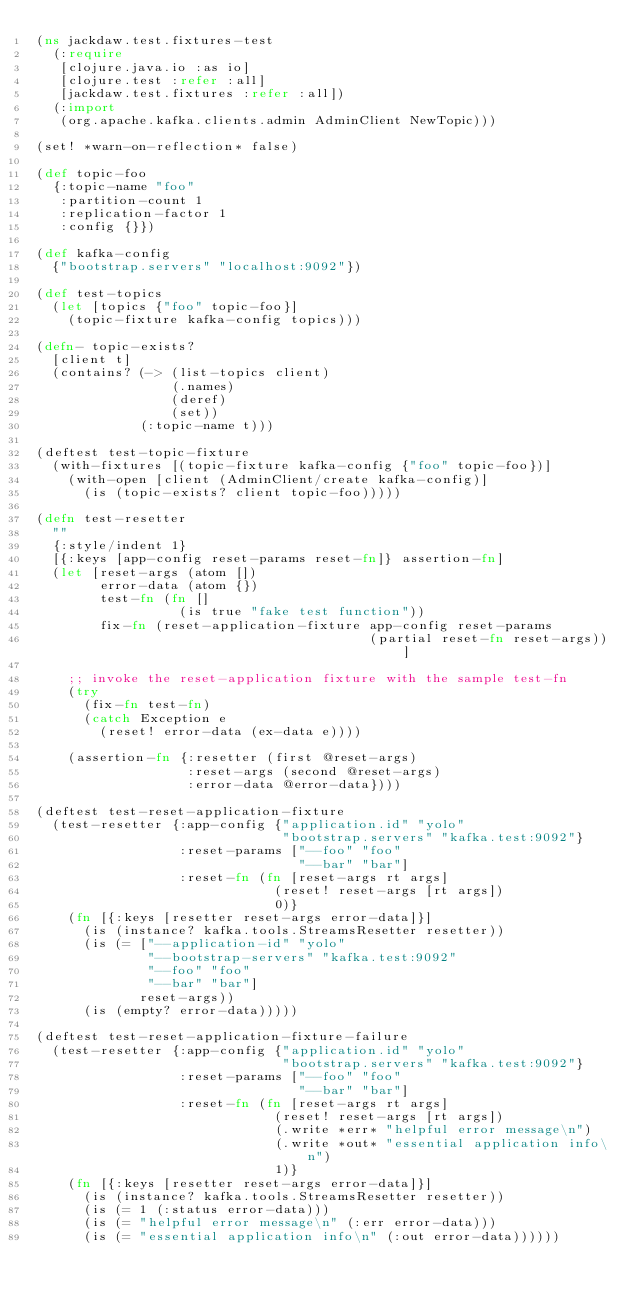Convert code to text. <code><loc_0><loc_0><loc_500><loc_500><_Clojure_>(ns jackdaw.test.fixtures-test
  (:require
   [clojure.java.io :as io]
   [clojure.test :refer :all]
   [jackdaw.test.fixtures :refer :all])
  (:import
   (org.apache.kafka.clients.admin AdminClient NewTopic)))

(set! *warn-on-reflection* false)

(def topic-foo
  {:topic-name "foo"
   :partition-count 1
   :replication-factor 1
   :config {}})

(def kafka-config
  {"bootstrap.servers" "localhost:9092"})

(def test-topics
  (let [topics {"foo" topic-foo}]
    (topic-fixture kafka-config topics)))

(defn- topic-exists?
  [client t]
  (contains? (-> (list-topics client)
                 (.names)
                 (deref)
                 (set))
             (:topic-name t)))

(deftest test-topic-fixture
  (with-fixtures [(topic-fixture kafka-config {"foo" topic-foo})]
    (with-open [client (AdminClient/create kafka-config)]
      (is (topic-exists? client topic-foo)))))

(defn test-resetter
  ""
  {:style/indent 1}
  [{:keys [app-config reset-params reset-fn]} assertion-fn]
  (let [reset-args (atom [])
        error-data (atom {})
        test-fn (fn []
                  (is true "fake test function"))
        fix-fn (reset-application-fixture app-config reset-params
                                          (partial reset-fn reset-args))]

    ;; invoke the reset-application fixture with the sample test-fn
    (try
      (fix-fn test-fn)
      (catch Exception e
        (reset! error-data (ex-data e))))

    (assertion-fn {:resetter (first @reset-args)
                   :reset-args (second @reset-args)
                   :error-data @error-data})))

(deftest test-reset-application-fixture
  (test-resetter {:app-config {"application.id" "yolo"
                               "bootstrap.servers" "kafka.test:9092"}
                  :reset-params ["--foo" "foo"
                                 "--bar" "bar"]
                  :reset-fn (fn [reset-args rt args]
                              (reset! reset-args [rt args])
                              0)}
    (fn [{:keys [resetter reset-args error-data]}]
      (is (instance? kafka.tools.StreamsResetter resetter))
      (is (= ["--application-id" "yolo"
              "--bootstrap-servers" "kafka.test:9092"
              "--foo" "foo"
              "--bar" "bar"]
             reset-args))
      (is (empty? error-data)))))

(deftest test-reset-application-fixture-failure
  (test-resetter {:app-config {"application.id" "yolo"
                               "bootstrap.servers" "kafka.test:9092"}
                  :reset-params ["--foo" "foo"
                                 "--bar" "bar"]
                  :reset-fn (fn [reset-args rt args]
                              (reset! reset-args [rt args])
                              (.write *err* "helpful error message\n")
                              (.write *out* "essential application info\n")
                              1)}
    (fn [{:keys [resetter reset-args error-data]}]
      (is (instance? kafka.tools.StreamsResetter resetter))
      (is (= 1 (:status error-data)))
      (is (= "helpful error message\n" (:err error-data)))
      (is (= "essential application info\n" (:out error-data))))))
</code> 